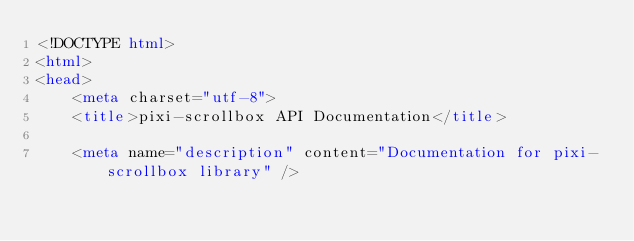Convert code to text. <code><loc_0><loc_0><loc_500><loc_500><_HTML_><!DOCTYPE html>
<html>
<head>
    <meta charset="utf-8">
    <title>pixi-scrollbox API Documentation</title>
    
    <meta name="description" content="Documentation for pixi-scrollbox library" />
    </code> 